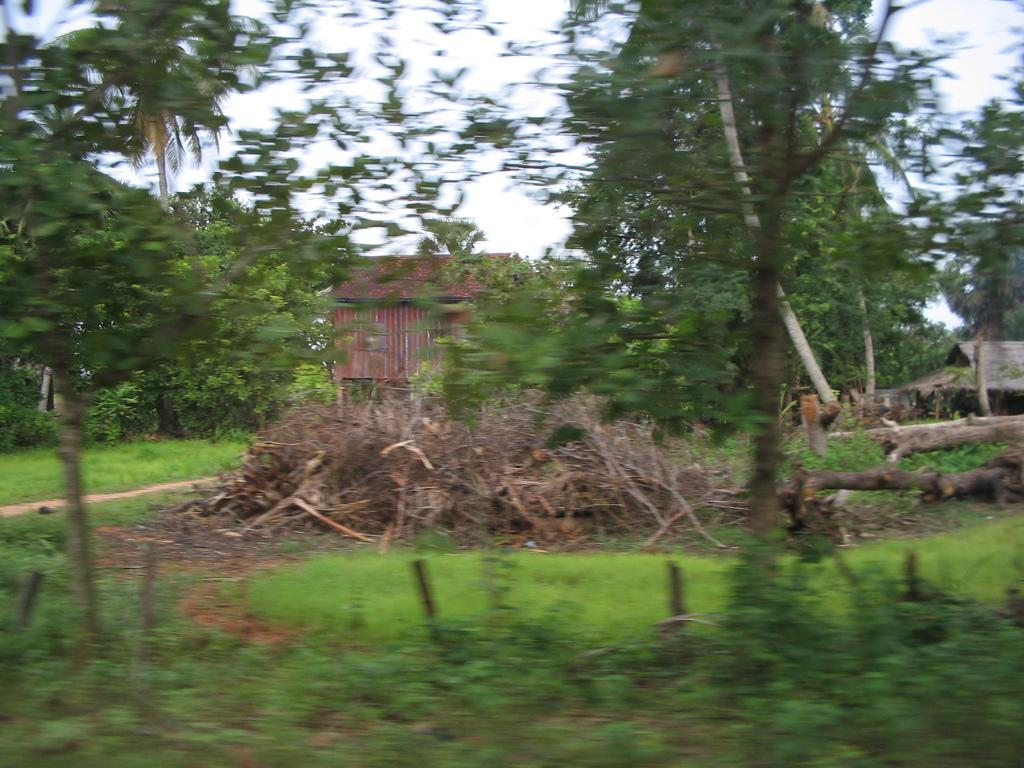What type of structures are located in the center of the image? There are huts in the center of the image. What else can be seen in the center of the image? There are wood logs visible in the center of the image. What type of vegetation is visible in the background of the image? There are trees, grass, and plants in the background of the image. What part of the natural environment is visible in the background of the image? The ground and the sky are visible in the background of the image. Where is the nearest airport in the image? There is no airport present in the image. Can you see a chessboard or chess pieces in the image? There is no chessboard or chess pieces visible in the image. 